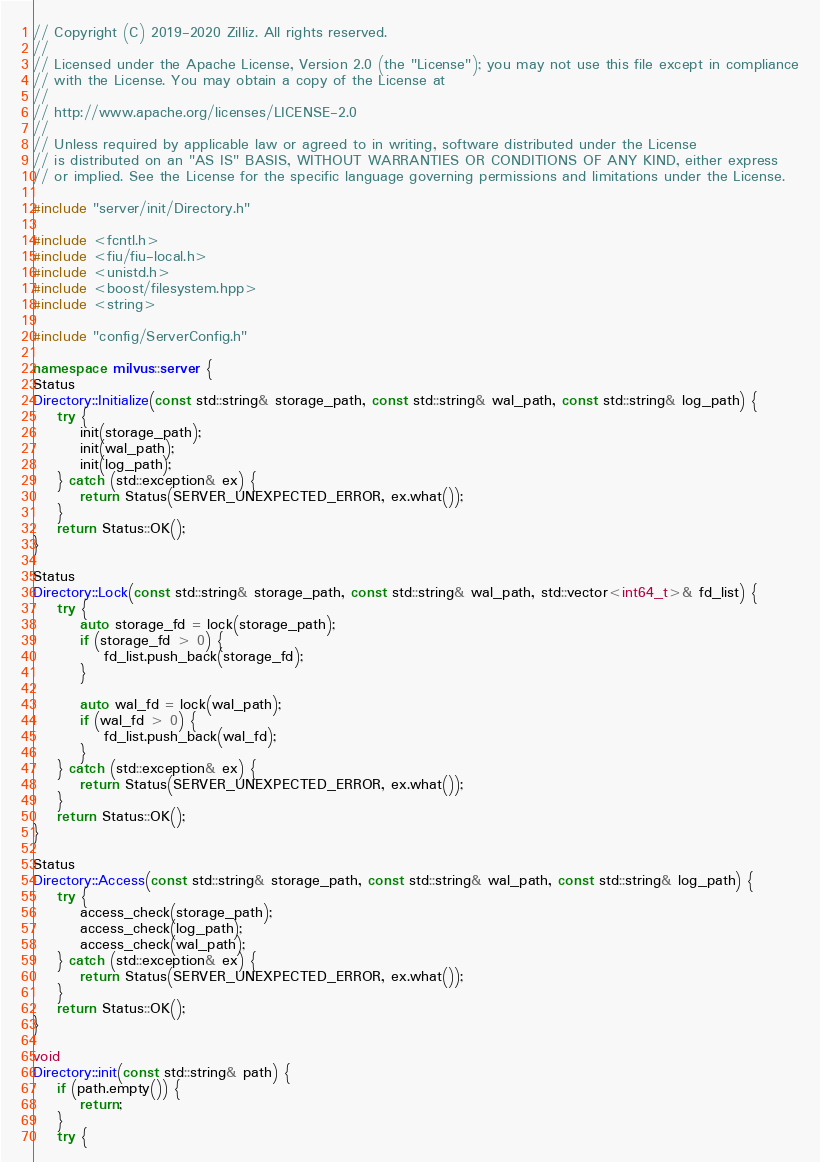Convert code to text. <code><loc_0><loc_0><loc_500><loc_500><_C++_>// Copyright (C) 2019-2020 Zilliz. All rights reserved.
//
// Licensed under the Apache License, Version 2.0 (the "License"); you may not use this file except in compliance
// with the License. You may obtain a copy of the License at
//
// http://www.apache.org/licenses/LICENSE-2.0
//
// Unless required by applicable law or agreed to in writing, software distributed under the License
// is distributed on an "AS IS" BASIS, WITHOUT WARRANTIES OR CONDITIONS OF ANY KIND, either express
// or implied. See the License for the specific language governing permissions and limitations under the License.

#include "server/init/Directory.h"

#include <fcntl.h>
#include <fiu/fiu-local.h>
#include <unistd.h>
#include <boost/filesystem.hpp>
#include <string>

#include "config/ServerConfig.h"

namespace milvus::server {
Status
Directory::Initialize(const std::string& storage_path, const std::string& wal_path, const std::string& log_path) {
    try {
        init(storage_path);
        init(wal_path);
        init(log_path);
    } catch (std::exception& ex) {
        return Status(SERVER_UNEXPECTED_ERROR, ex.what());
    }
    return Status::OK();
}

Status
Directory::Lock(const std::string& storage_path, const std::string& wal_path, std::vector<int64_t>& fd_list) {
    try {
        auto storage_fd = lock(storage_path);
        if (storage_fd > 0) {
            fd_list.push_back(storage_fd);
        }

        auto wal_fd = lock(wal_path);
        if (wal_fd > 0) {
            fd_list.push_back(wal_fd);
        }
    } catch (std::exception& ex) {
        return Status(SERVER_UNEXPECTED_ERROR, ex.what());
    }
    return Status::OK();
}

Status
Directory::Access(const std::string& storage_path, const std::string& wal_path, const std::string& log_path) {
    try {
        access_check(storage_path);
        access_check(log_path);
        access_check(wal_path);
    } catch (std::exception& ex) {
        return Status(SERVER_UNEXPECTED_ERROR, ex.what());
    }
    return Status::OK();
}

void
Directory::init(const std::string& path) {
    if (path.empty()) {
        return;
    }
    try {</code> 